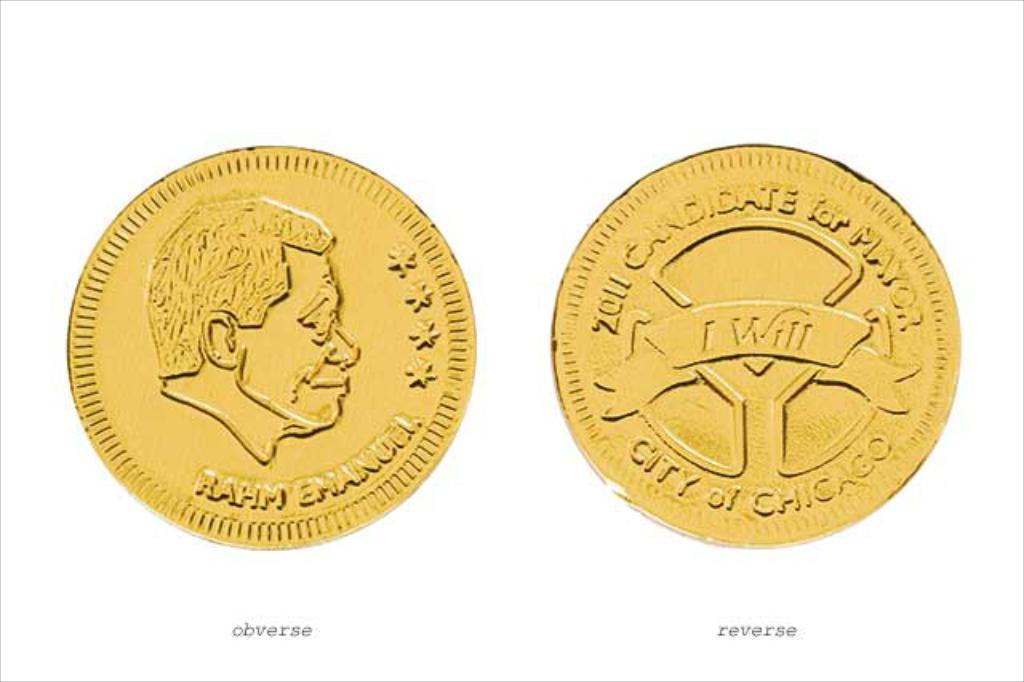<image>
Provide a brief description of the given image. Rahm Emanuel candidate for mayor is etched onto this collector's coin. 